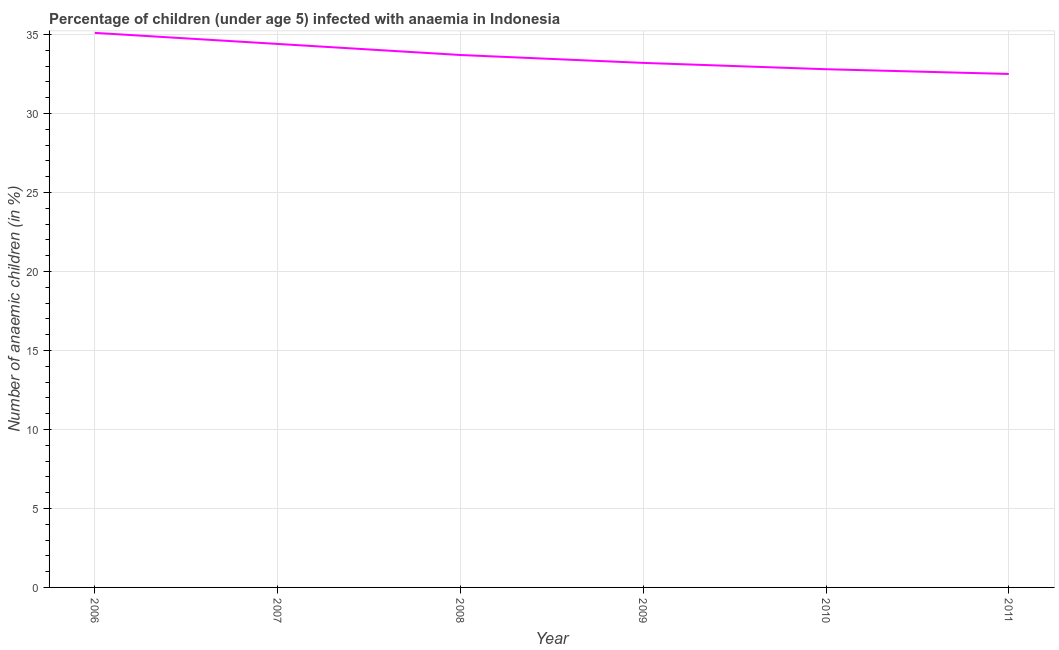What is the number of anaemic children in 2008?
Your response must be concise. 33.7. Across all years, what is the maximum number of anaemic children?
Give a very brief answer. 35.1. Across all years, what is the minimum number of anaemic children?
Ensure brevity in your answer.  32.5. In which year was the number of anaemic children maximum?
Give a very brief answer. 2006. In which year was the number of anaemic children minimum?
Ensure brevity in your answer.  2011. What is the sum of the number of anaemic children?
Your response must be concise. 201.7. What is the difference between the number of anaemic children in 2007 and 2008?
Keep it short and to the point. 0.7. What is the average number of anaemic children per year?
Offer a very short reply. 33.62. What is the median number of anaemic children?
Offer a very short reply. 33.45. Do a majority of the years between 2007 and 2008 (inclusive) have number of anaemic children greater than 16 %?
Keep it short and to the point. Yes. What is the ratio of the number of anaemic children in 2007 to that in 2010?
Keep it short and to the point. 1.05. What is the difference between the highest and the second highest number of anaemic children?
Provide a short and direct response. 0.7. Is the sum of the number of anaemic children in 2007 and 2011 greater than the maximum number of anaemic children across all years?
Your answer should be compact. Yes. What is the difference between the highest and the lowest number of anaemic children?
Your response must be concise. 2.6. Does the number of anaemic children monotonically increase over the years?
Keep it short and to the point. No. How many lines are there?
Provide a short and direct response. 1. What is the difference between two consecutive major ticks on the Y-axis?
Offer a very short reply. 5. Are the values on the major ticks of Y-axis written in scientific E-notation?
Give a very brief answer. No. Does the graph contain any zero values?
Your answer should be very brief. No. Does the graph contain grids?
Make the answer very short. Yes. What is the title of the graph?
Your answer should be very brief. Percentage of children (under age 5) infected with anaemia in Indonesia. What is the label or title of the Y-axis?
Provide a succinct answer. Number of anaemic children (in %). What is the Number of anaemic children (in %) of 2006?
Give a very brief answer. 35.1. What is the Number of anaemic children (in %) of 2007?
Provide a succinct answer. 34.4. What is the Number of anaemic children (in %) in 2008?
Your answer should be very brief. 33.7. What is the Number of anaemic children (in %) of 2009?
Make the answer very short. 33.2. What is the Number of anaemic children (in %) of 2010?
Ensure brevity in your answer.  32.8. What is the Number of anaemic children (in %) in 2011?
Offer a very short reply. 32.5. What is the difference between the Number of anaemic children (in %) in 2006 and 2009?
Provide a short and direct response. 1.9. What is the difference between the Number of anaemic children (in %) in 2008 and 2009?
Provide a short and direct response. 0.5. What is the difference between the Number of anaemic children (in %) in 2008 and 2010?
Your answer should be very brief. 0.9. What is the difference between the Number of anaemic children (in %) in 2010 and 2011?
Provide a succinct answer. 0.3. What is the ratio of the Number of anaemic children (in %) in 2006 to that in 2008?
Make the answer very short. 1.04. What is the ratio of the Number of anaemic children (in %) in 2006 to that in 2009?
Give a very brief answer. 1.06. What is the ratio of the Number of anaemic children (in %) in 2006 to that in 2010?
Offer a very short reply. 1.07. What is the ratio of the Number of anaemic children (in %) in 2007 to that in 2009?
Ensure brevity in your answer.  1.04. What is the ratio of the Number of anaemic children (in %) in 2007 to that in 2010?
Make the answer very short. 1.05. What is the ratio of the Number of anaemic children (in %) in 2007 to that in 2011?
Your response must be concise. 1.06. What is the ratio of the Number of anaemic children (in %) in 2008 to that in 2011?
Make the answer very short. 1.04. 